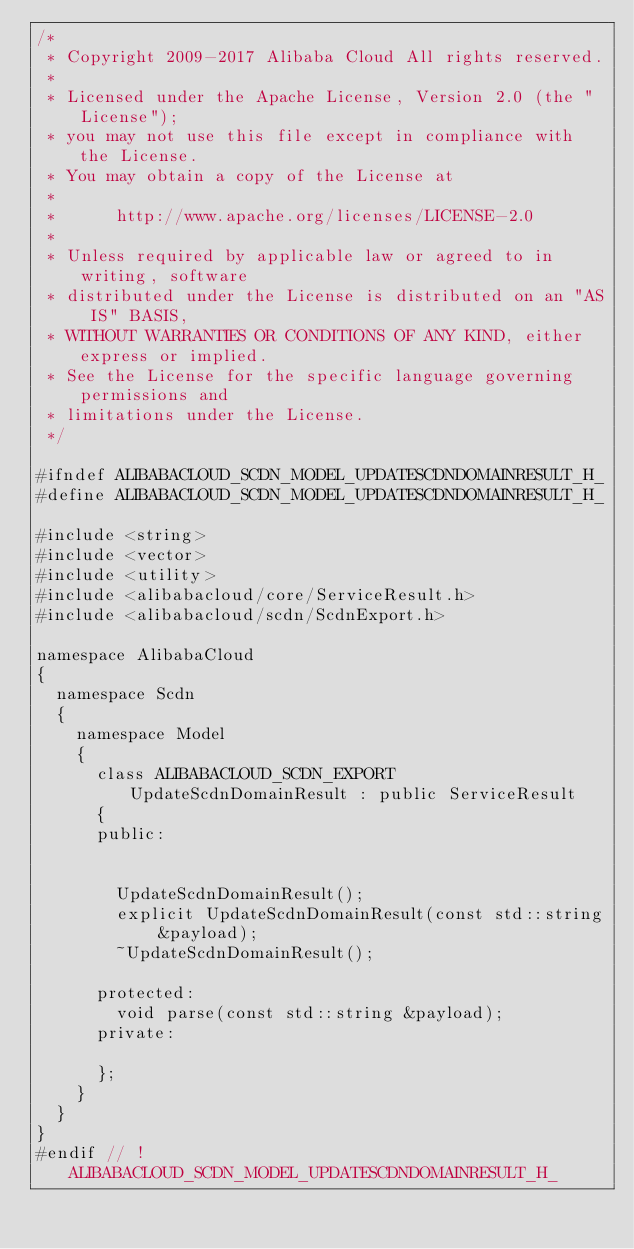<code> <loc_0><loc_0><loc_500><loc_500><_C_>/*
 * Copyright 2009-2017 Alibaba Cloud All rights reserved.
 * 
 * Licensed under the Apache License, Version 2.0 (the "License");
 * you may not use this file except in compliance with the License.
 * You may obtain a copy of the License at
 * 
 *      http://www.apache.org/licenses/LICENSE-2.0
 * 
 * Unless required by applicable law or agreed to in writing, software
 * distributed under the License is distributed on an "AS IS" BASIS,
 * WITHOUT WARRANTIES OR CONDITIONS OF ANY KIND, either express or implied.
 * See the License for the specific language governing permissions and
 * limitations under the License.
 */

#ifndef ALIBABACLOUD_SCDN_MODEL_UPDATESCDNDOMAINRESULT_H_
#define ALIBABACLOUD_SCDN_MODEL_UPDATESCDNDOMAINRESULT_H_

#include <string>
#include <vector>
#include <utility>
#include <alibabacloud/core/ServiceResult.h>
#include <alibabacloud/scdn/ScdnExport.h>

namespace AlibabaCloud
{
	namespace Scdn
	{
		namespace Model
		{
			class ALIBABACLOUD_SCDN_EXPORT UpdateScdnDomainResult : public ServiceResult
			{
			public:


				UpdateScdnDomainResult();
				explicit UpdateScdnDomainResult(const std::string &payload);
				~UpdateScdnDomainResult();

			protected:
				void parse(const std::string &payload);
			private:

			};
		}
	}
}
#endif // !ALIBABACLOUD_SCDN_MODEL_UPDATESCDNDOMAINRESULT_H_</code> 